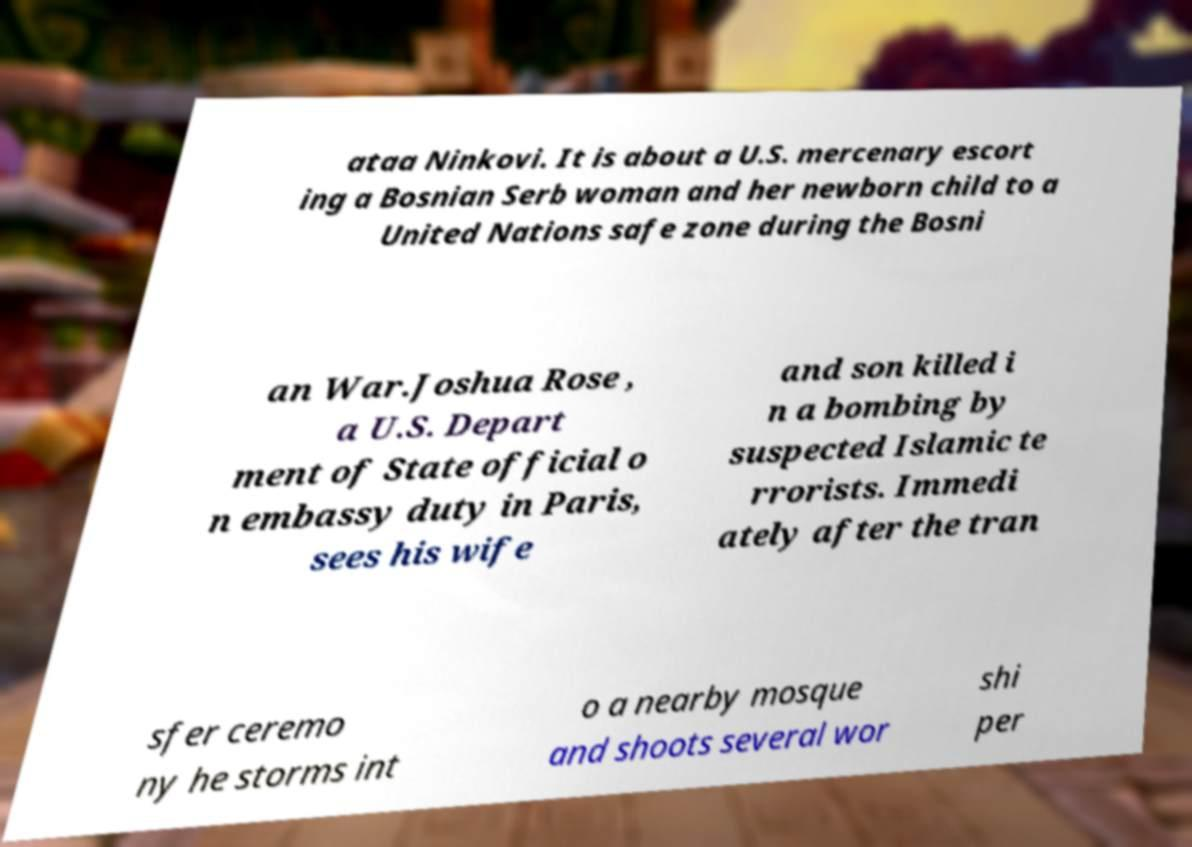Could you extract and type out the text from this image? ataa Ninkovi. It is about a U.S. mercenary escort ing a Bosnian Serb woman and her newborn child to a United Nations safe zone during the Bosni an War.Joshua Rose , a U.S. Depart ment of State official o n embassy duty in Paris, sees his wife and son killed i n a bombing by suspected Islamic te rrorists. Immedi ately after the tran sfer ceremo ny he storms int o a nearby mosque and shoots several wor shi per 